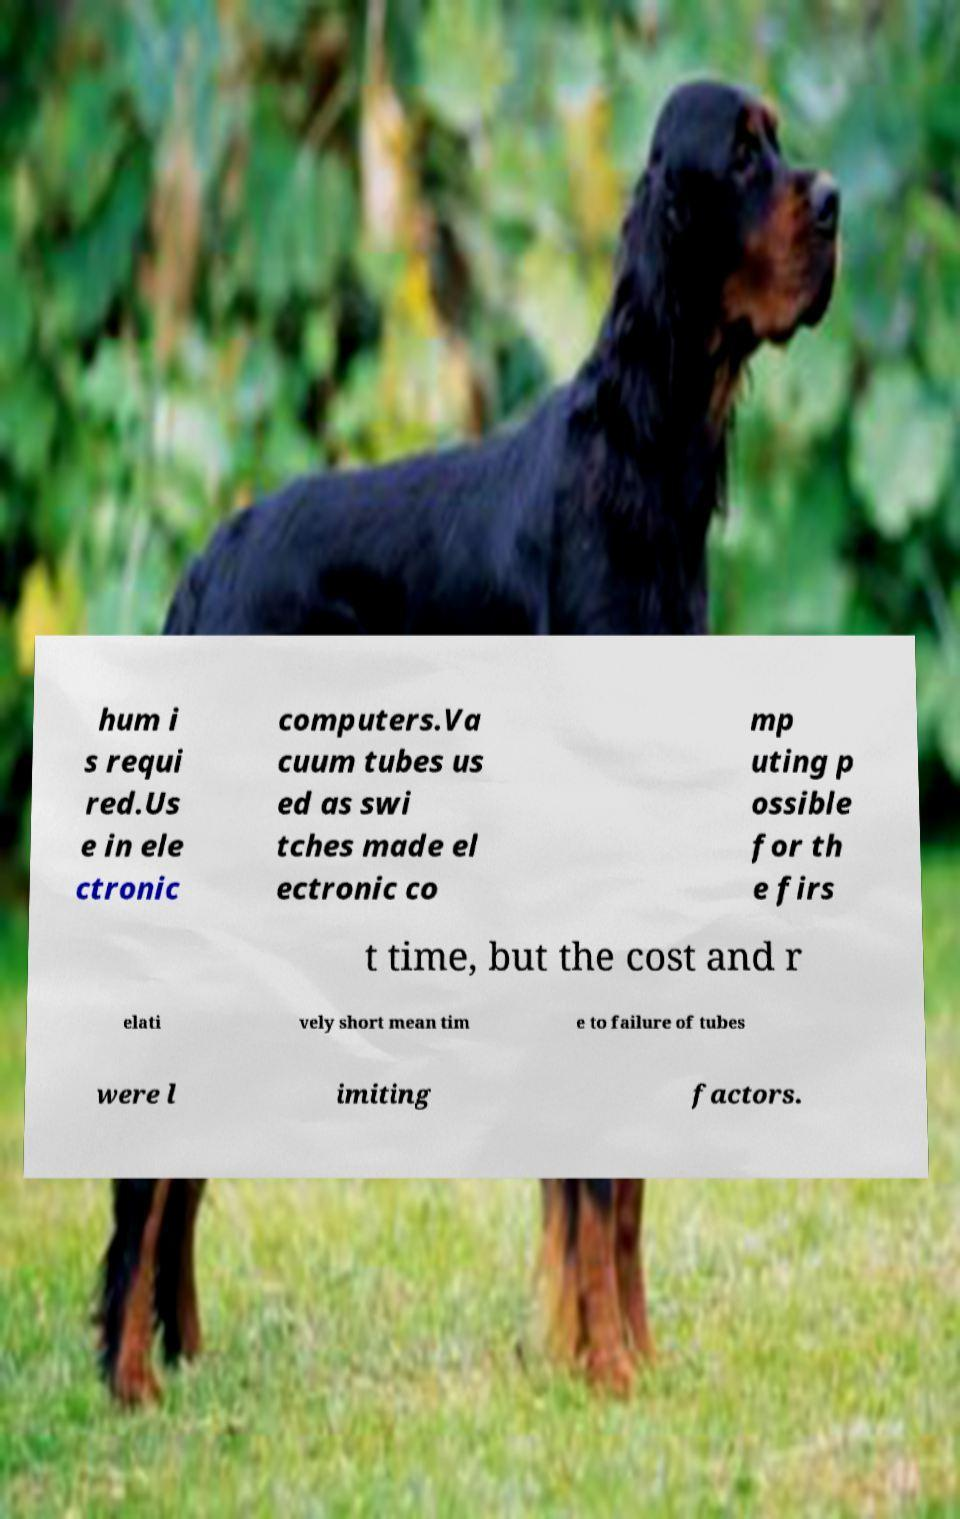Please identify and transcribe the text found in this image. hum i s requi red.Us e in ele ctronic computers.Va cuum tubes us ed as swi tches made el ectronic co mp uting p ossible for th e firs t time, but the cost and r elati vely short mean tim e to failure of tubes were l imiting factors. 